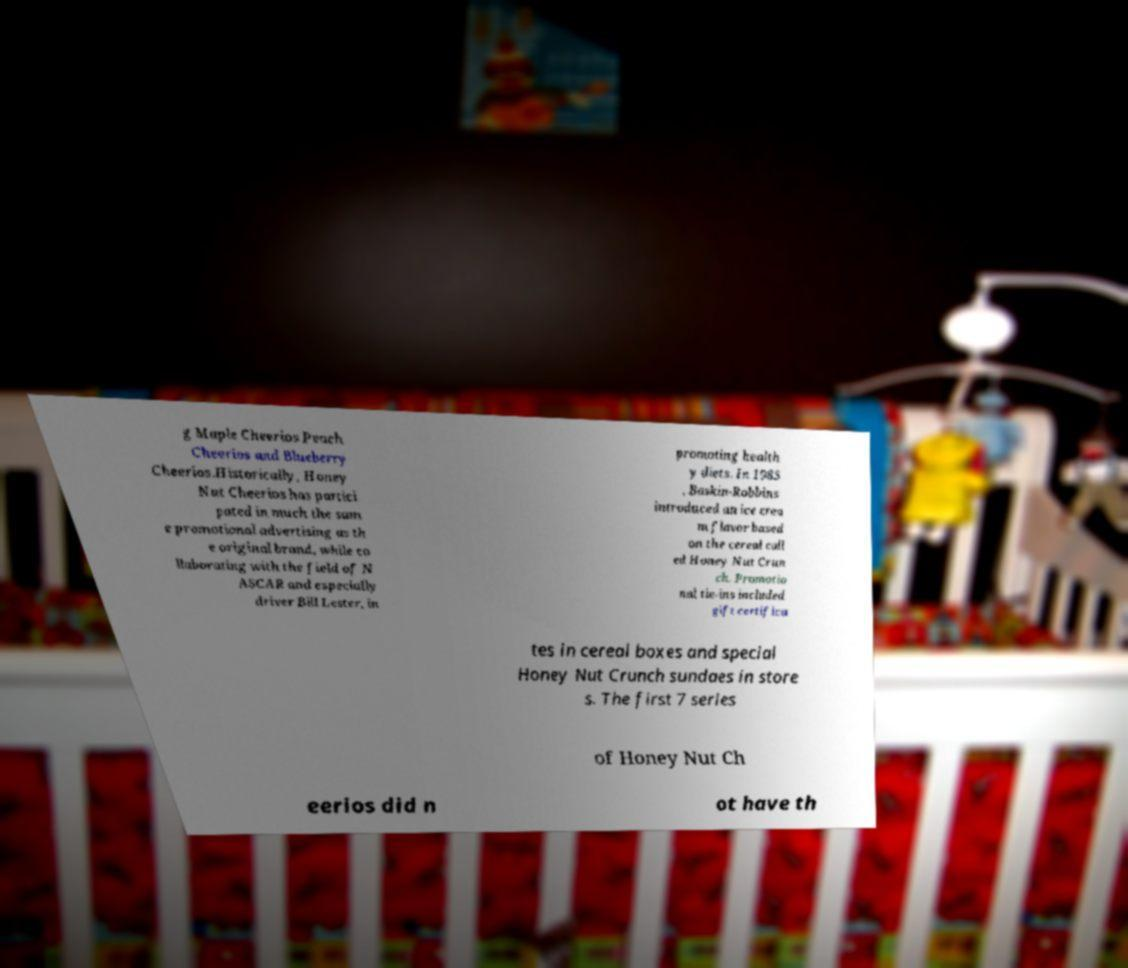I need the written content from this picture converted into text. Can you do that? g Maple Cheerios Peach Cheerios and Blueberry Cheerios.Historically, Honey Nut Cheerios has partici pated in much the sam e promotional advertising as th e original brand, while co llaborating with the field of N ASCAR and especially driver Bill Lester, in promoting health y diets. In 1985 , Baskin-Robbins introduced an ice crea m flavor based on the cereal call ed Honey Nut Crun ch. Promotio nal tie-ins included gift certifica tes in cereal boxes and special Honey Nut Crunch sundaes in store s. The first 7 series of Honey Nut Ch eerios did n ot have th 